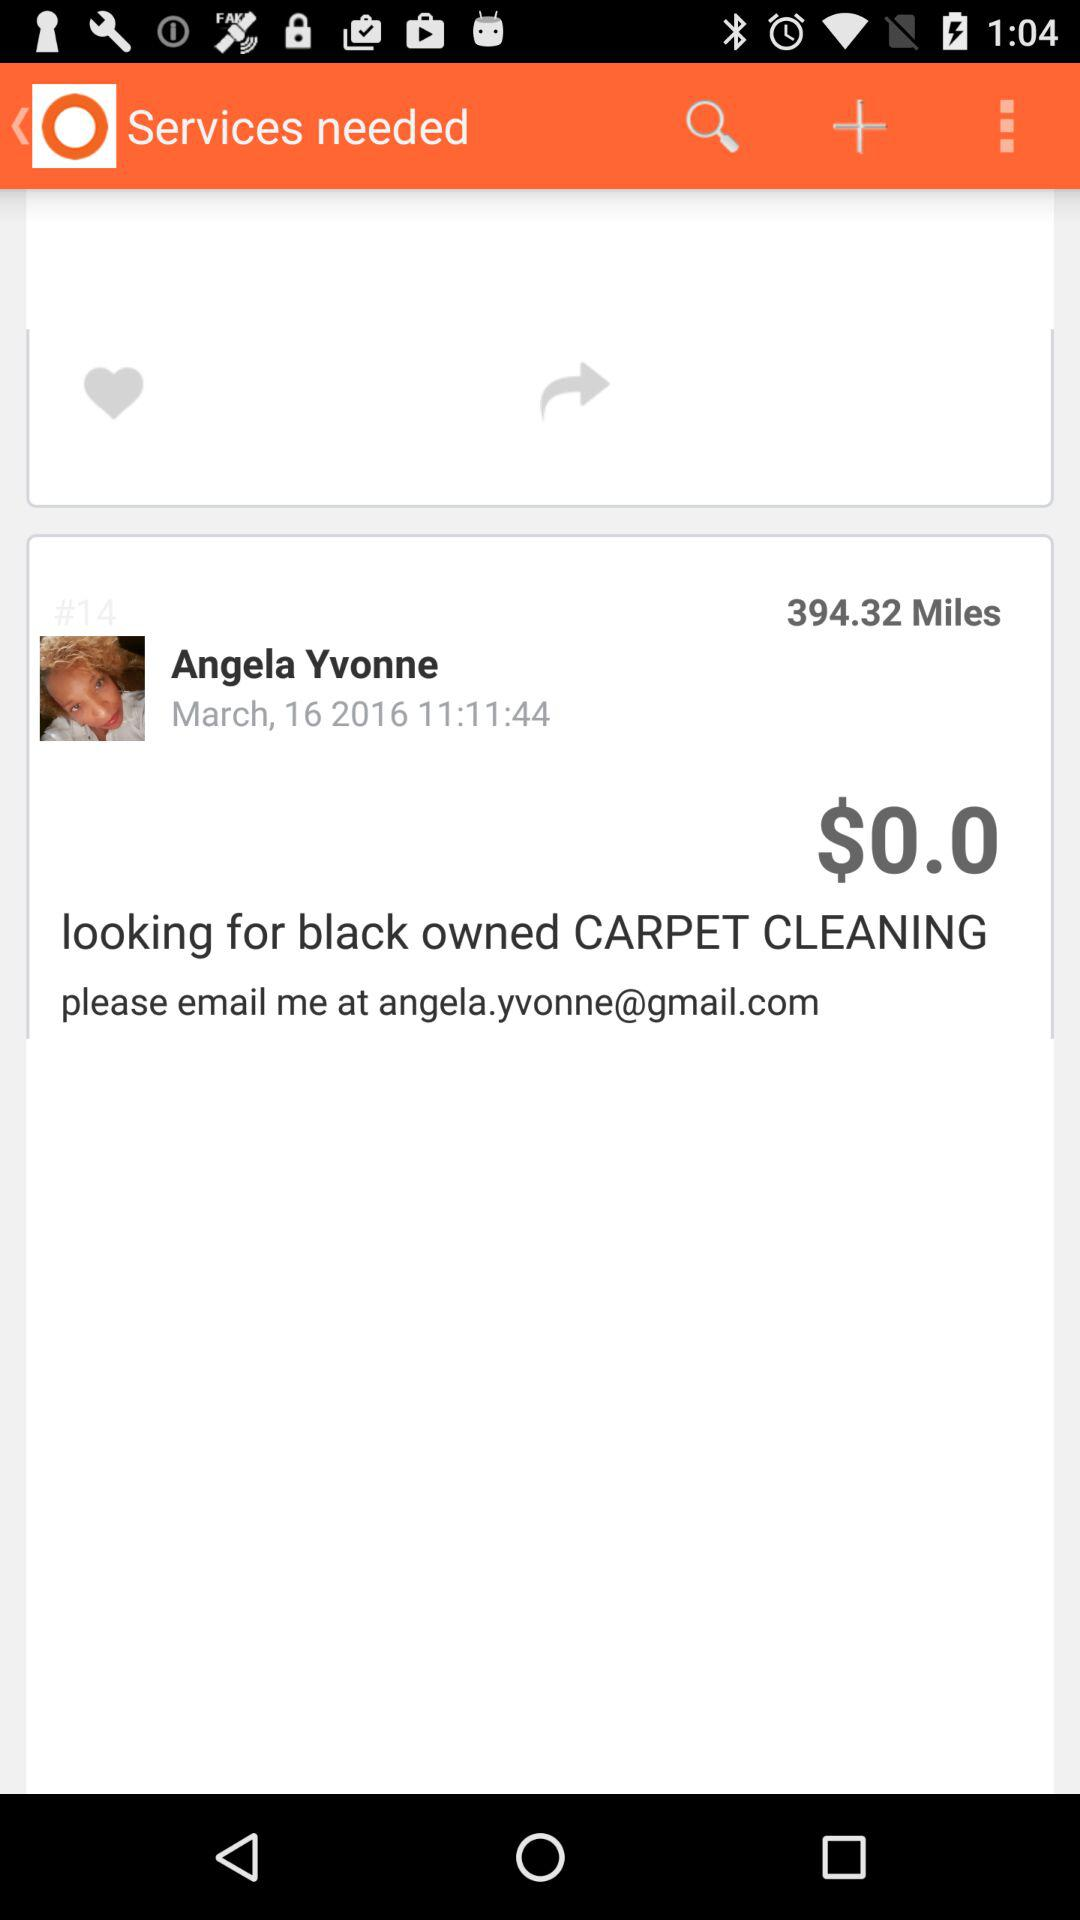When was it published? It was published on March 16, 2016 at 11:11:44. 